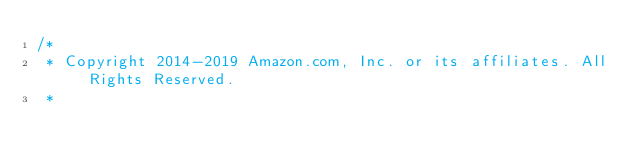Convert code to text. <code><loc_0><loc_0><loc_500><loc_500><_Java_>/*
 * Copyright 2014-2019 Amazon.com, Inc. or its affiliates. All Rights Reserved.
 * </code> 